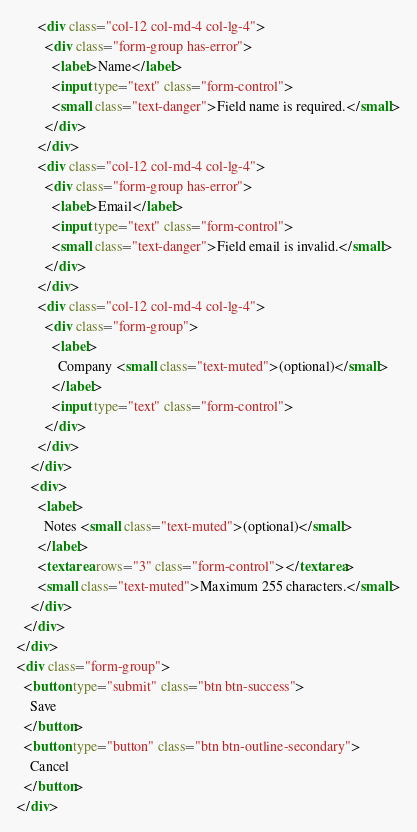<code> <loc_0><loc_0><loc_500><loc_500><_HTML_>      <div class="col-12 col-md-4 col-lg-4">
        <div class="form-group has-error">
          <label>Name</label>
          <input type="text" class="form-control">
          <small class="text-danger">Field name is required.</small>
        </div>
      </div>
      <div class="col-12 col-md-4 col-lg-4">
        <div class="form-group has-error">
          <label>Email</label>
          <input type="text" class="form-control">
          <small class="text-danger">Field email is invalid.</small>
        </div>
      </div>
      <div class="col-12 col-md-4 col-lg-4">
        <div class="form-group">
          <label>
            Company <small class="text-muted">(optional)</small>
          </label>
          <input type="text" class="form-control">
        </div>
      </div>
    </div>
    <div>
      <label>
        Notes <small class="text-muted">(optional)</small>
      </label>
      <textarea rows="3" class="form-control"></textarea>
      <small class="text-muted">Maximum 255 characters.</small>
    </div>
  </div>
</div>
<div class="form-group">
  <button type="submit" class="btn btn-success">
    Save
  </button>
  <button type="button" class="btn btn-outline-secondary">
    Cancel
  </button>
</div>
</code> 